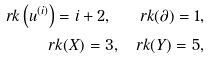<formula> <loc_0><loc_0><loc_500><loc_500>r k \left ( u ^ { ( i ) } \right ) = i + 2 , \quad r k ( \partial ) = 1 , \\ r k ( X ) = 3 , \quad r k ( Y ) = 5 ,</formula> 